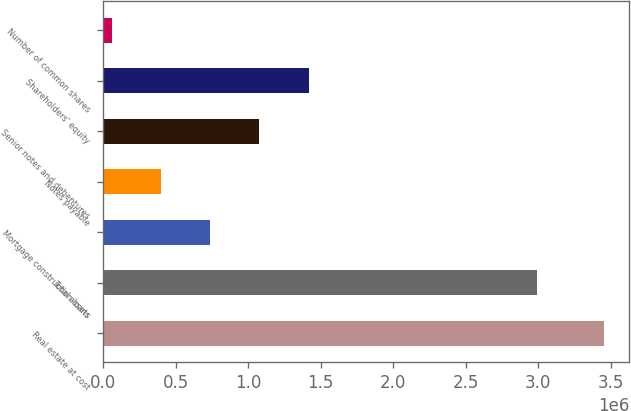<chart> <loc_0><loc_0><loc_500><loc_500><bar_chart><fcel>Real estate at cost<fcel>Total assets<fcel>Mortgage construction loans<fcel>Notes payable<fcel>Senior notes and debentures<fcel>Shareholders' equity<fcel>Number of common shares<nl><fcel>3.45285e+06<fcel>2.9893e+06<fcel>737486<fcel>398066<fcel>1.07691e+06<fcel>1.41633e+06<fcel>58646<nl></chart> 